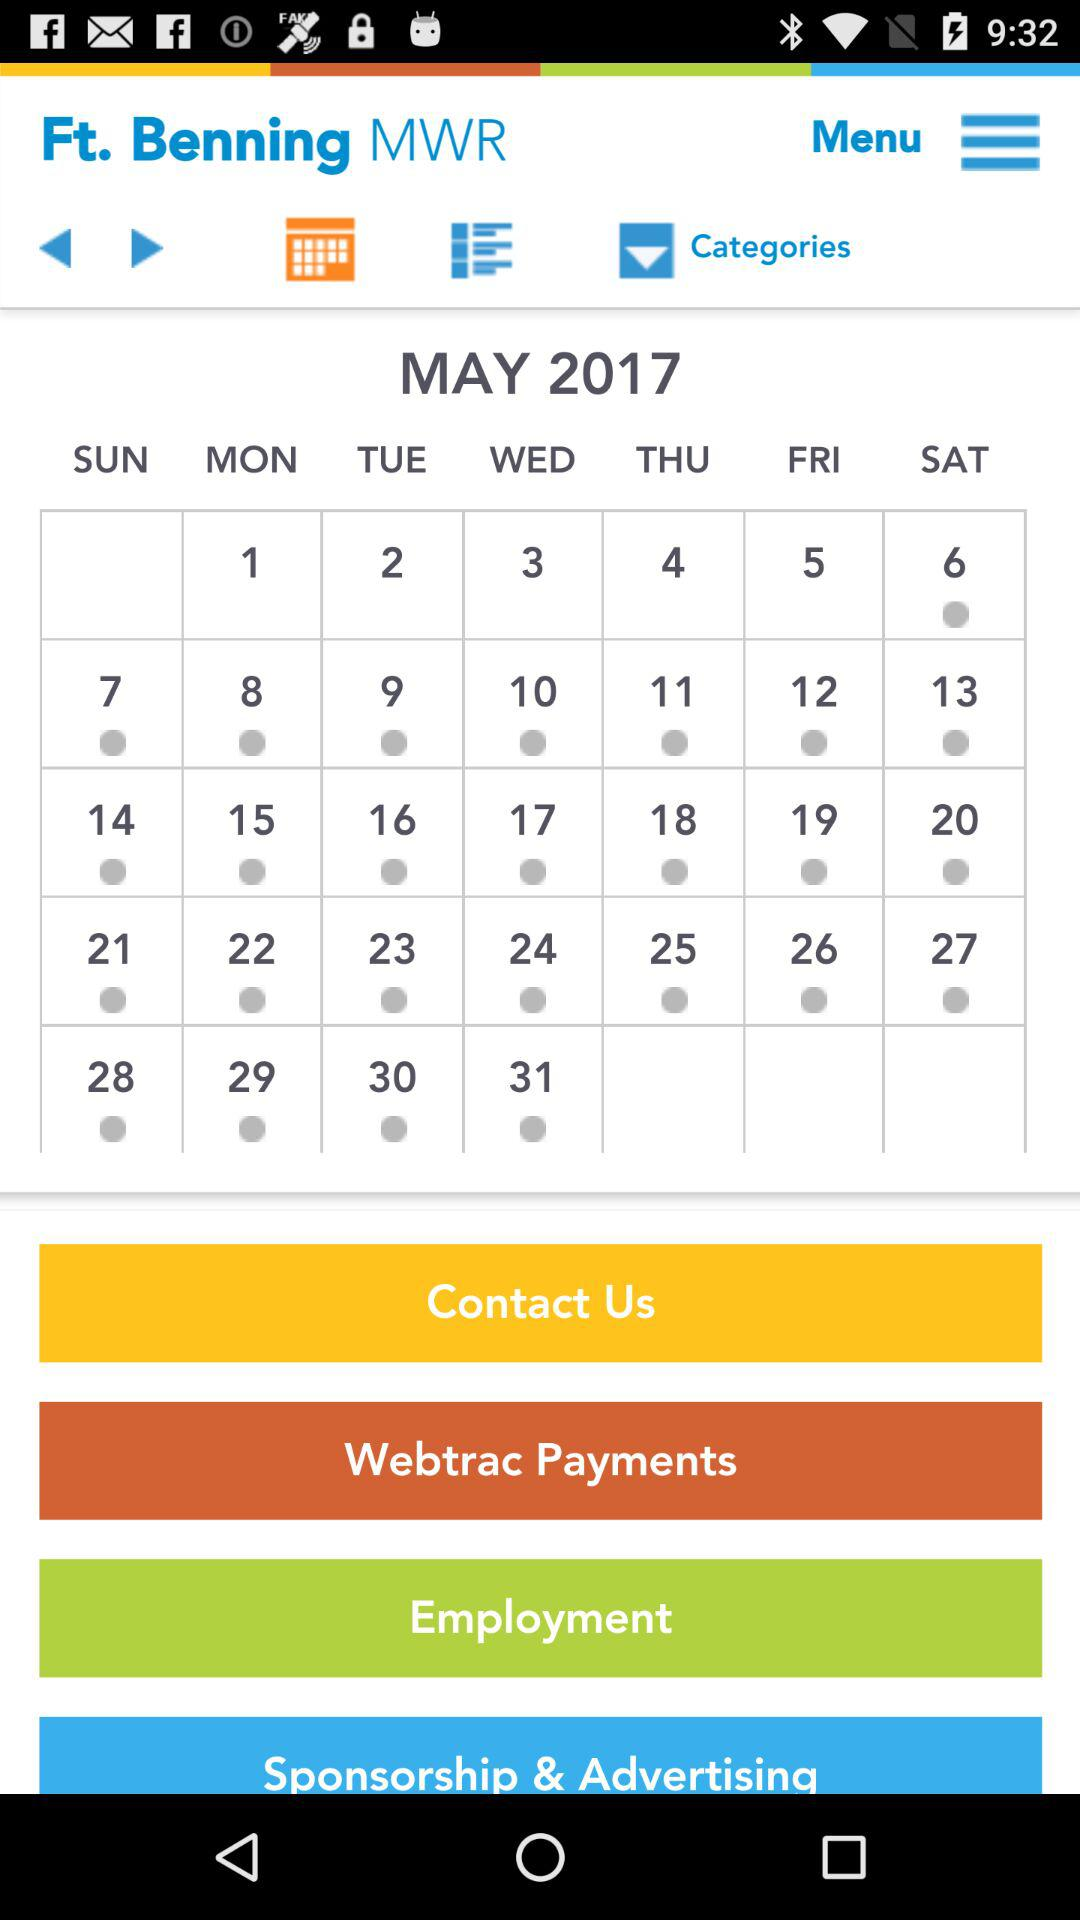What is the year and month? The year and month are May and 2017, respectively. 